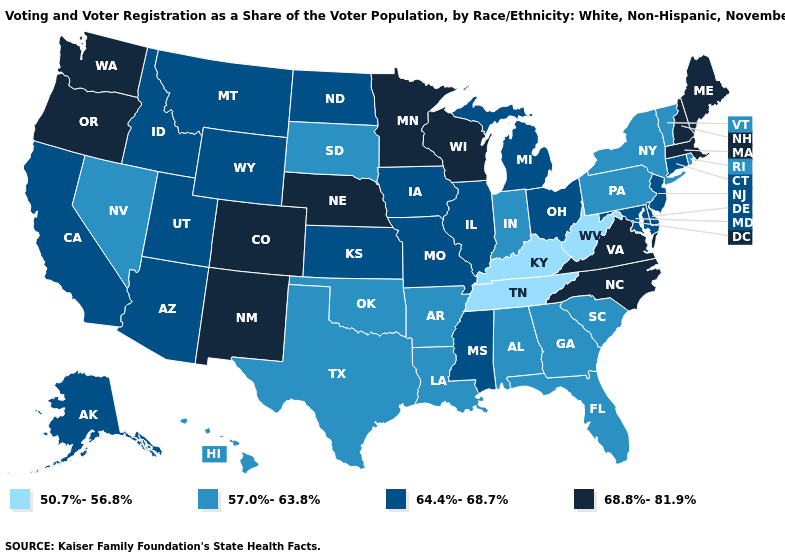Does Hawaii have a lower value than Tennessee?
Short answer required. No. What is the lowest value in the USA?
Quick response, please. 50.7%-56.8%. What is the value of Michigan?
Write a very short answer. 64.4%-68.7%. Which states hav the highest value in the South?
Short answer required. North Carolina, Virginia. Name the states that have a value in the range 64.4%-68.7%?
Short answer required. Alaska, Arizona, California, Connecticut, Delaware, Idaho, Illinois, Iowa, Kansas, Maryland, Michigan, Mississippi, Missouri, Montana, New Jersey, North Dakota, Ohio, Utah, Wyoming. Among the states that border Nebraska , which have the lowest value?
Keep it brief. South Dakota. What is the value of Illinois?
Give a very brief answer. 64.4%-68.7%. How many symbols are there in the legend?
Keep it brief. 4. Which states have the lowest value in the USA?
Write a very short answer. Kentucky, Tennessee, West Virginia. Is the legend a continuous bar?
Concise answer only. No. Does Michigan have a lower value than Nebraska?
Answer briefly. Yes. Does Georgia have the highest value in the USA?
Keep it brief. No. Among the states that border Iowa , does Nebraska have the highest value?
Give a very brief answer. Yes. Name the states that have a value in the range 64.4%-68.7%?
Keep it brief. Alaska, Arizona, California, Connecticut, Delaware, Idaho, Illinois, Iowa, Kansas, Maryland, Michigan, Mississippi, Missouri, Montana, New Jersey, North Dakota, Ohio, Utah, Wyoming. Does Kansas have a higher value than Florida?
Write a very short answer. Yes. 